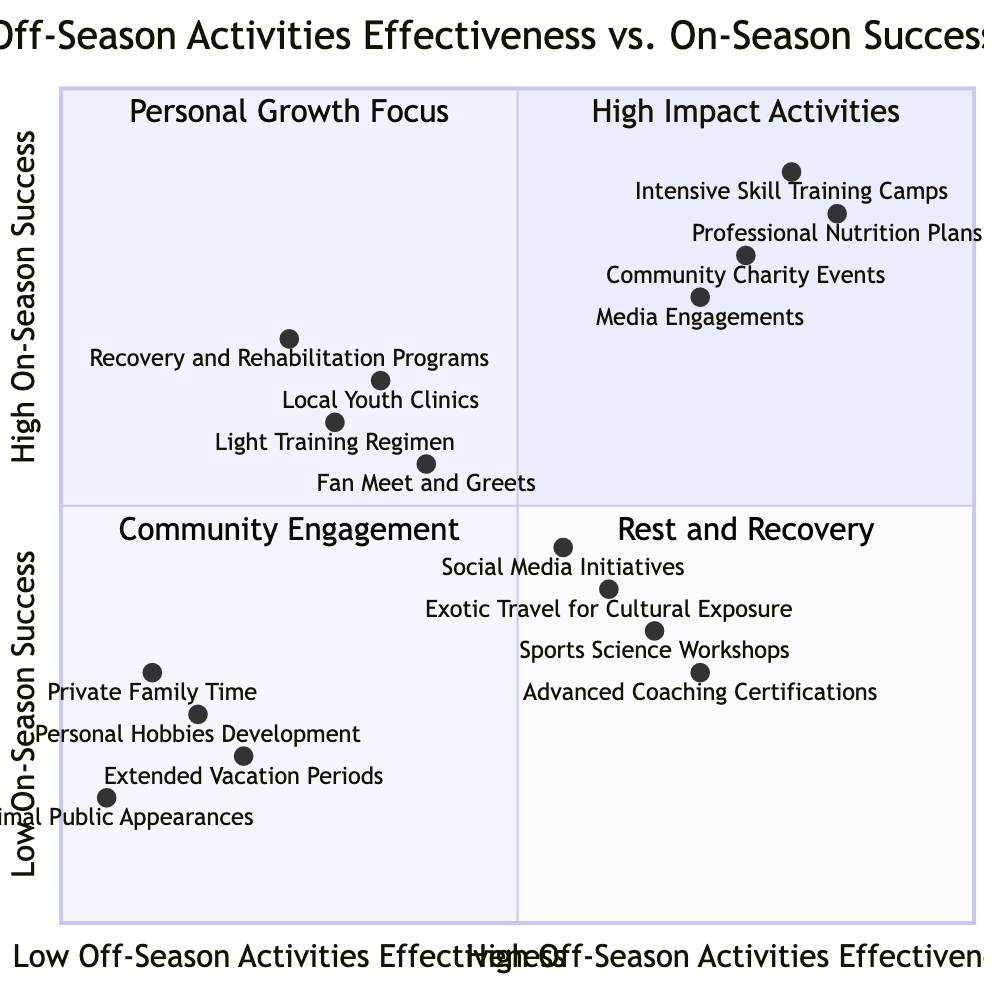What activities fall into the "High Off-Season Activities Effectiveness, High On-Season Success" quadrant? The quadrant includes "Intensive Skill Training Camps", "Professional Nutrition Plans", "Community Charity Events", and "Media Engagements". These activities have been categorized based on their effectiveness in the off-season and their correlation to on-season success.
Answer: Intensive Skill Training Camps, Professional Nutrition Plans, Community Charity Events, Media Engagements How many activities are categorized under "High Off-Season Activities Effectiveness, Low On-Season Success"? The quadrant lists four activities: "Exotic Travel for Cultural Exposure", "Advanced Coaching Certifications", "Sports Science Workshops", and "Social Media Initiatives". Thus, the count is four.
Answer: 4 Which activity has the lowest effectiveness in the "Low Off-Season Activities Effectiveness, Low On-Season Success" quadrant? In this quadrant, "Minimal Public Appearances" is found at the bottom-left, indicating it has the lowest effectiveness in this category compared to the others listed.
Answer: Minimal Public Appearances Is there an overlap between the "Recovery and Rehabilitation Programs" and any other quadrant? "Recovery and Rehabilitation Programs" is placed in the "Low Off-Season Activities Effectiveness, High On-Season Success" quadrant. It does not overlap with others because all the quadrants represent distinct effectiveness and success combinations.
Answer: No Which quadrant contains the most community engagement activities? The "High Off-Season Activities Effectiveness, High On-Season Success" quadrant lists "Community Charity Events", indicating a strong link to community engagement along with other high-impact activities.
Answer: High Off-Season Activities Effectiveness, High On-Season Success What is the relationship between "Social Media Initiatives" and "Advanced Coaching Certifications"? "Social Media Initiatives" is in the "High Off-Season Activities Effectiveness, Low On-Season Success" quadrant while "Advanced Coaching Certifications" is also in the same quadrant, indicating they share a similar effectiveness outcome but differ in on-season success.
Answer: Same quadrant How many total activities are plotted in the "Rest and Recovery" quadrant? The "Rest and Recovery" quadrant, "Low Off-Season Activities Effectiveness, Low On-Season Success", includes four activities: "Extended Vacation Periods", "Personal Hobbies Development", "Private Family Time", and "Minimal Public Appearances". Therefore, it has four total activities.
Answer: 4 Which activity shows the highest success rate in the "Community Engagement" quadrant? The activity "Community Charity Events" has a high on-season success rate of 0.8, making it the top performer in the "Community Engagement" quadrant.
Answer: Community Charity Events What activities are identified as focusing on personal growth according to the diagram? In the "Personal Growth Focus" quadrant, the activities are "Exotic Travel for Cultural Exposure", "Advanced Coaching Certifications", "Sports Science Workshops", and "Social Media Initiatives", indicating a focus on personal development during off-season activities.
Answer: Exotic Travel for Cultural Exposure, Advanced Coaching Certifications, Sports Science Workshops, Social Media Initiatives 